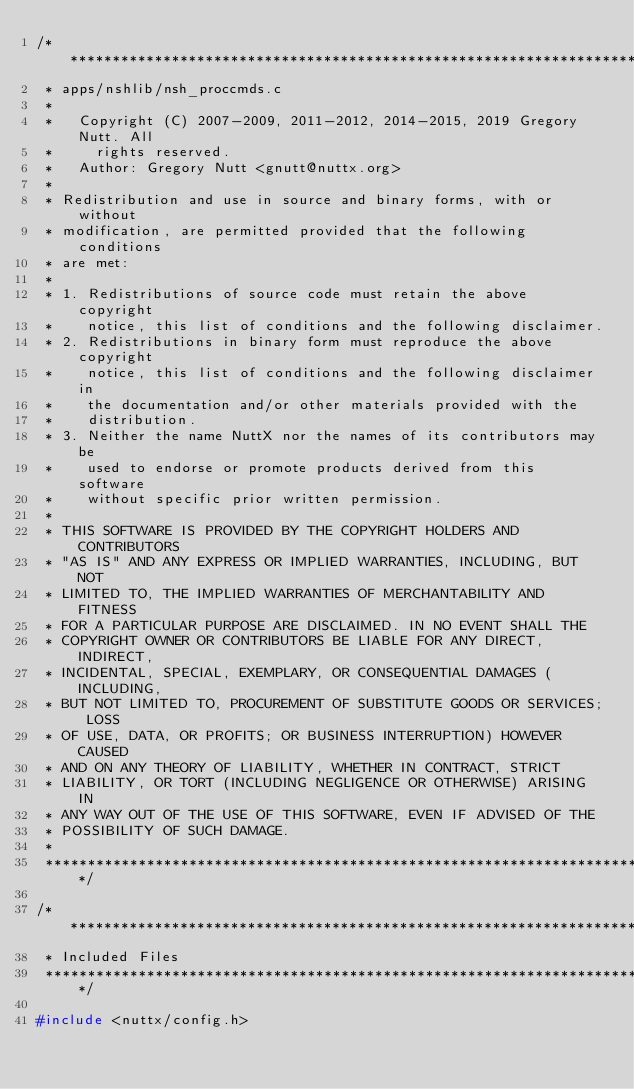<code> <loc_0><loc_0><loc_500><loc_500><_C_>/****************************************************************************
 * apps/nshlib/nsh_proccmds.c
 *
 *   Copyright (C) 2007-2009, 2011-2012, 2014-2015, 2019 Gregory Nutt. All
 *     rights reserved.
 *   Author: Gregory Nutt <gnutt@nuttx.org>
 *
 * Redistribution and use in source and binary forms, with or without
 * modification, are permitted provided that the following conditions
 * are met:
 *
 * 1. Redistributions of source code must retain the above copyright
 *    notice, this list of conditions and the following disclaimer.
 * 2. Redistributions in binary form must reproduce the above copyright
 *    notice, this list of conditions and the following disclaimer in
 *    the documentation and/or other materials provided with the
 *    distribution.
 * 3. Neither the name NuttX nor the names of its contributors may be
 *    used to endorse or promote products derived from this software
 *    without specific prior written permission.
 *
 * THIS SOFTWARE IS PROVIDED BY THE COPYRIGHT HOLDERS AND CONTRIBUTORS
 * "AS IS" AND ANY EXPRESS OR IMPLIED WARRANTIES, INCLUDING, BUT NOT
 * LIMITED TO, THE IMPLIED WARRANTIES OF MERCHANTABILITY AND FITNESS
 * FOR A PARTICULAR PURPOSE ARE DISCLAIMED. IN NO EVENT SHALL THE
 * COPYRIGHT OWNER OR CONTRIBUTORS BE LIABLE FOR ANY DIRECT, INDIRECT,
 * INCIDENTAL, SPECIAL, EXEMPLARY, OR CONSEQUENTIAL DAMAGES (INCLUDING,
 * BUT NOT LIMITED TO, PROCUREMENT OF SUBSTITUTE GOODS OR SERVICES; LOSS
 * OF USE, DATA, OR PROFITS; OR BUSINESS INTERRUPTION) HOWEVER CAUSED
 * AND ON ANY THEORY OF LIABILITY, WHETHER IN CONTRACT, STRICT
 * LIABILITY, OR TORT (INCLUDING NEGLIGENCE OR OTHERWISE) ARISING IN
 * ANY WAY OUT OF THE USE OF THIS SOFTWARE, EVEN IF ADVISED OF THE
 * POSSIBILITY OF SUCH DAMAGE.
 *
 ****************************************************************************/

/****************************************************************************
 * Included Files
 ****************************************************************************/

#include <nuttx/config.h>
</code> 